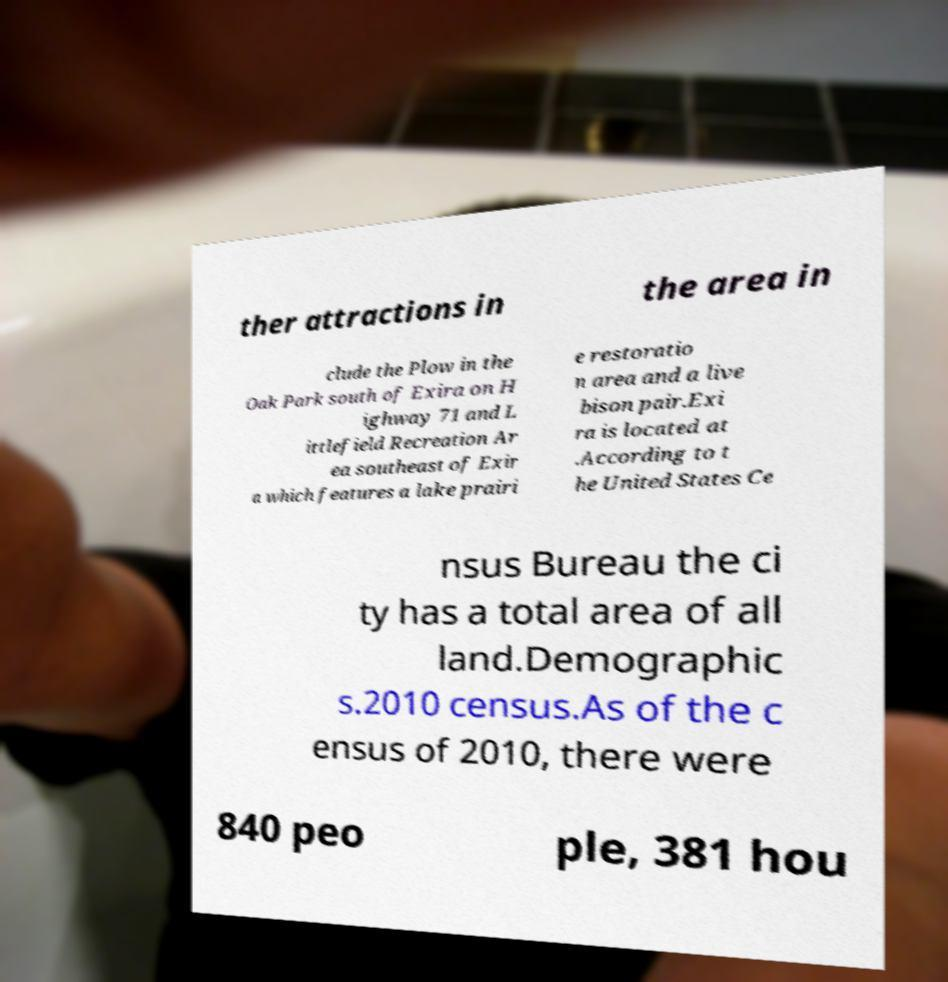There's text embedded in this image that I need extracted. Can you transcribe it verbatim? ther attractions in the area in clude the Plow in the Oak Park south of Exira on H ighway 71 and L ittlefield Recreation Ar ea southeast of Exir a which features a lake prairi e restoratio n area and a live bison pair.Exi ra is located at .According to t he United States Ce nsus Bureau the ci ty has a total area of all land.Demographic s.2010 census.As of the c ensus of 2010, there were 840 peo ple, 381 hou 